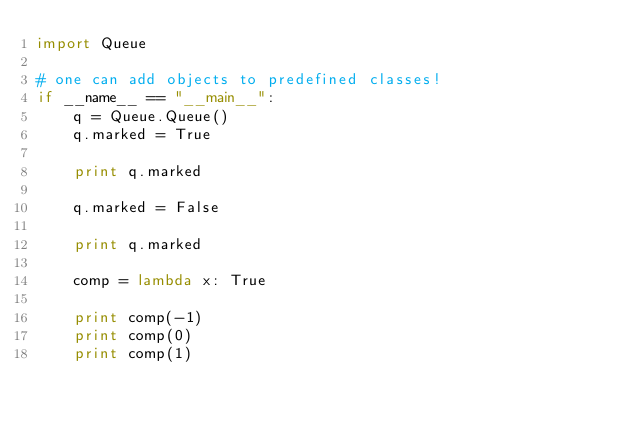<code> <loc_0><loc_0><loc_500><loc_500><_Python_>import Queue

# one can add objects to predefined classes!
if __name__ == "__main__":
	q = Queue.Queue()
	q.marked = True

	print q.marked 

	q.marked = False

	print q.marked

	comp = lambda x: True

	print comp(-1)	
	print comp(0)	
	print comp(1)	
</code> 